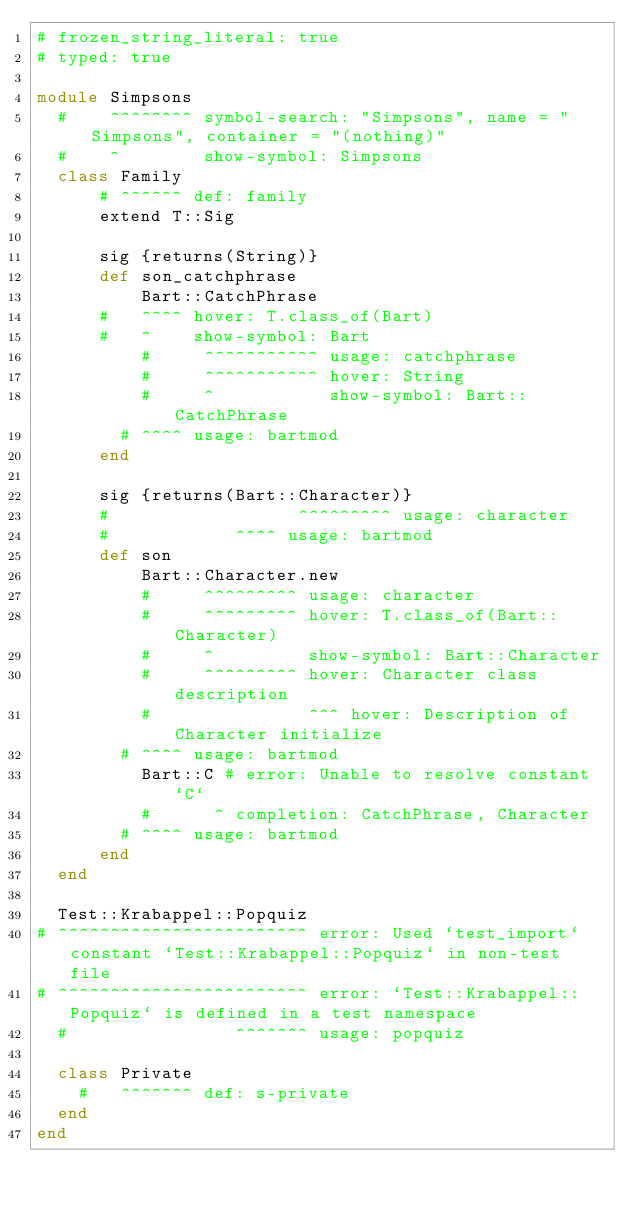<code> <loc_0><loc_0><loc_500><loc_500><_Ruby_># frozen_string_literal: true
# typed: true

module Simpsons
  #    ^^^^^^^^ symbol-search: "Simpsons", name = "Simpsons", container = "(nothing)"
  #    ^        show-symbol: Simpsons
  class Family
      # ^^^^^^ def: family
      extend T::Sig

      sig {returns(String)}
      def son_catchphrase
          Bart::CatchPhrase
      #   ^^^^ hover: T.class_of(Bart)
      #   ^    show-symbol: Bart
          #     ^^^^^^^^^^^ usage: catchphrase
          #     ^^^^^^^^^^^ hover: String
          #     ^           show-symbol: Bart::CatchPhrase
        # ^^^^ usage: bartmod
      end

      sig {returns(Bart::Character)}
      #                  ^^^^^^^^^ usage: character
      #            ^^^^ usage: bartmod
      def son
          Bart::Character.new
          #     ^^^^^^^^^ usage: character
          #     ^^^^^^^^^ hover: T.class_of(Bart::Character)
          #     ^         show-symbol: Bart::Character
          #     ^^^^^^^^^ hover: Character class description
          #               ^^^ hover: Description of Character initialize
        # ^^^^ usage: bartmod
          Bart::C # error: Unable to resolve constant `C`
          #      ^ completion: CatchPhrase, Character
        # ^^^^ usage: bartmod
      end
  end

  Test::Krabappel::Popquiz
# ^^^^^^^^^^^^^^^^^^^^^^^^ error: Used `test_import` constant `Test::Krabappel::Popquiz` in non-test file
# ^^^^^^^^^^^^^^^^^^^^^^^^ error: `Test::Krabappel::Popquiz` is defined in a test namespace
  #                ^^^^^^^ usage: popquiz

  class Private
    #   ^^^^^^^ def: s-private
  end
end
</code> 